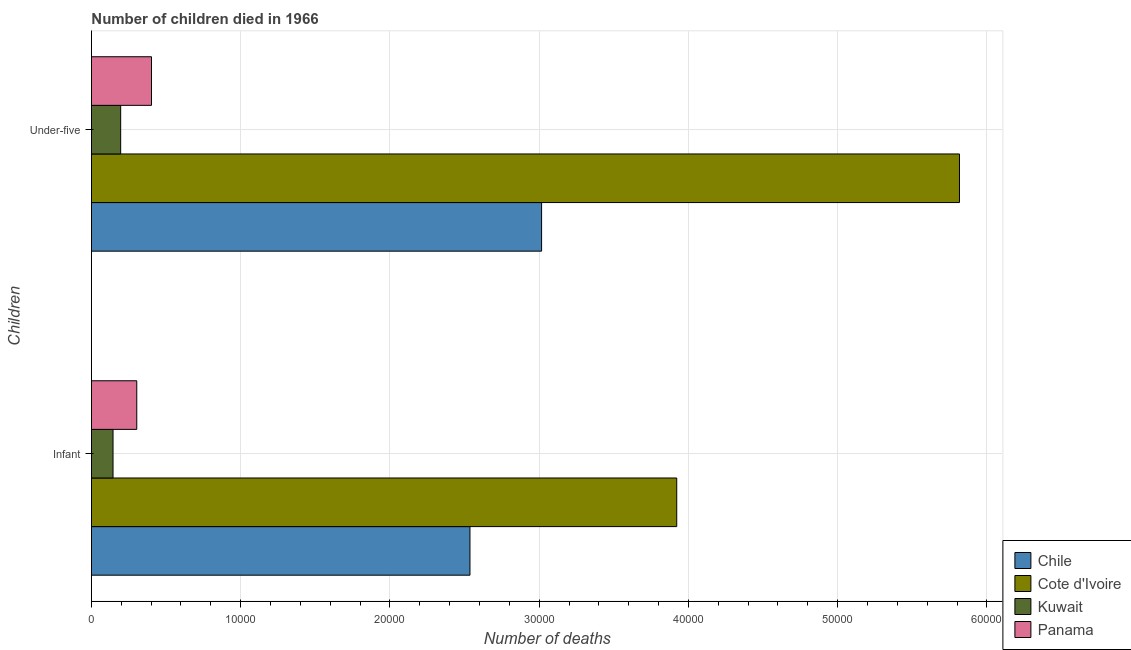How many different coloured bars are there?
Give a very brief answer. 4. Are the number of bars per tick equal to the number of legend labels?
Your response must be concise. Yes. Are the number of bars on each tick of the Y-axis equal?
Provide a short and direct response. Yes. How many bars are there on the 1st tick from the top?
Provide a succinct answer. 4. How many bars are there on the 1st tick from the bottom?
Your answer should be compact. 4. What is the label of the 2nd group of bars from the top?
Your answer should be compact. Infant. What is the number of infant deaths in Panama?
Your answer should be compact. 3038. Across all countries, what is the maximum number of under-five deaths?
Make the answer very short. 5.82e+04. In which country was the number of under-five deaths maximum?
Keep it short and to the point. Cote d'Ivoire. In which country was the number of under-five deaths minimum?
Ensure brevity in your answer.  Kuwait. What is the total number of under-five deaths in the graph?
Ensure brevity in your answer.  9.43e+04. What is the difference between the number of under-five deaths in Chile and that in Kuwait?
Your response must be concise. 2.82e+04. What is the difference between the number of under-five deaths in Cote d'Ivoire and the number of infant deaths in Panama?
Give a very brief answer. 5.51e+04. What is the average number of under-five deaths per country?
Offer a terse response. 2.36e+04. What is the difference between the number of infant deaths and number of under-five deaths in Kuwait?
Your answer should be compact. -512. In how many countries, is the number of under-five deaths greater than 20000 ?
Provide a succinct answer. 2. What is the ratio of the number of under-five deaths in Chile to that in Panama?
Your answer should be compact. 7.49. In how many countries, is the number of infant deaths greater than the average number of infant deaths taken over all countries?
Make the answer very short. 2. What does the 2nd bar from the top in Infant represents?
Keep it short and to the point. Kuwait. What does the 4th bar from the bottom in Under-five represents?
Ensure brevity in your answer.  Panama. How many countries are there in the graph?
Make the answer very short. 4. How many legend labels are there?
Offer a terse response. 4. What is the title of the graph?
Your answer should be very brief. Number of children died in 1966. What is the label or title of the X-axis?
Give a very brief answer. Number of deaths. What is the label or title of the Y-axis?
Your answer should be very brief. Children. What is the Number of deaths of Chile in Infant?
Keep it short and to the point. 2.54e+04. What is the Number of deaths in Cote d'Ivoire in Infant?
Your response must be concise. 3.92e+04. What is the Number of deaths in Kuwait in Infant?
Provide a short and direct response. 1448. What is the Number of deaths in Panama in Infant?
Provide a succinct answer. 3038. What is the Number of deaths in Chile in Under-five?
Provide a short and direct response. 3.02e+04. What is the Number of deaths in Cote d'Ivoire in Under-five?
Provide a short and direct response. 5.82e+04. What is the Number of deaths of Kuwait in Under-five?
Provide a short and direct response. 1960. What is the Number of deaths of Panama in Under-five?
Your answer should be very brief. 4025. Across all Children, what is the maximum Number of deaths in Chile?
Provide a short and direct response. 3.02e+04. Across all Children, what is the maximum Number of deaths in Cote d'Ivoire?
Your response must be concise. 5.82e+04. Across all Children, what is the maximum Number of deaths in Kuwait?
Give a very brief answer. 1960. Across all Children, what is the maximum Number of deaths in Panama?
Offer a very short reply. 4025. Across all Children, what is the minimum Number of deaths in Chile?
Provide a succinct answer. 2.54e+04. Across all Children, what is the minimum Number of deaths of Cote d'Ivoire?
Make the answer very short. 3.92e+04. Across all Children, what is the minimum Number of deaths in Kuwait?
Keep it short and to the point. 1448. Across all Children, what is the minimum Number of deaths in Panama?
Ensure brevity in your answer.  3038. What is the total Number of deaths of Chile in the graph?
Provide a short and direct response. 5.55e+04. What is the total Number of deaths of Cote d'Ivoire in the graph?
Your answer should be compact. 9.74e+04. What is the total Number of deaths in Kuwait in the graph?
Provide a short and direct response. 3408. What is the total Number of deaths of Panama in the graph?
Ensure brevity in your answer.  7063. What is the difference between the Number of deaths of Chile in Infant and that in Under-five?
Ensure brevity in your answer.  -4799. What is the difference between the Number of deaths in Cote d'Ivoire in Infant and that in Under-five?
Give a very brief answer. -1.89e+04. What is the difference between the Number of deaths of Kuwait in Infant and that in Under-five?
Your response must be concise. -512. What is the difference between the Number of deaths in Panama in Infant and that in Under-five?
Ensure brevity in your answer.  -987. What is the difference between the Number of deaths of Chile in Infant and the Number of deaths of Cote d'Ivoire in Under-five?
Your answer should be compact. -3.28e+04. What is the difference between the Number of deaths in Chile in Infant and the Number of deaths in Kuwait in Under-five?
Provide a succinct answer. 2.34e+04. What is the difference between the Number of deaths of Chile in Infant and the Number of deaths of Panama in Under-five?
Provide a succinct answer. 2.13e+04. What is the difference between the Number of deaths of Cote d'Ivoire in Infant and the Number of deaths of Kuwait in Under-five?
Offer a very short reply. 3.73e+04. What is the difference between the Number of deaths in Cote d'Ivoire in Infant and the Number of deaths in Panama in Under-five?
Offer a terse response. 3.52e+04. What is the difference between the Number of deaths in Kuwait in Infant and the Number of deaths in Panama in Under-five?
Your response must be concise. -2577. What is the average Number of deaths of Chile per Children?
Ensure brevity in your answer.  2.78e+04. What is the average Number of deaths of Cote d'Ivoire per Children?
Your response must be concise. 4.87e+04. What is the average Number of deaths in Kuwait per Children?
Offer a very short reply. 1704. What is the average Number of deaths in Panama per Children?
Your response must be concise. 3531.5. What is the difference between the Number of deaths in Chile and Number of deaths in Cote d'Ivoire in Infant?
Give a very brief answer. -1.39e+04. What is the difference between the Number of deaths in Chile and Number of deaths in Kuwait in Infant?
Your response must be concise. 2.39e+04. What is the difference between the Number of deaths in Chile and Number of deaths in Panama in Infant?
Make the answer very short. 2.23e+04. What is the difference between the Number of deaths in Cote d'Ivoire and Number of deaths in Kuwait in Infant?
Give a very brief answer. 3.78e+04. What is the difference between the Number of deaths of Cote d'Ivoire and Number of deaths of Panama in Infant?
Ensure brevity in your answer.  3.62e+04. What is the difference between the Number of deaths in Kuwait and Number of deaths in Panama in Infant?
Offer a very short reply. -1590. What is the difference between the Number of deaths in Chile and Number of deaths in Cote d'Ivoire in Under-five?
Provide a succinct answer. -2.80e+04. What is the difference between the Number of deaths of Chile and Number of deaths of Kuwait in Under-five?
Your response must be concise. 2.82e+04. What is the difference between the Number of deaths of Chile and Number of deaths of Panama in Under-five?
Give a very brief answer. 2.61e+04. What is the difference between the Number of deaths in Cote d'Ivoire and Number of deaths in Kuwait in Under-five?
Offer a terse response. 5.62e+04. What is the difference between the Number of deaths in Cote d'Ivoire and Number of deaths in Panama in Under-five?
Your answer should be compact. 5.41e+04. What is the difference between the Number of deaths of Kuwait and Number of deaths of Panama in Under-five?
Provide a short and direct response. -2065. What is the ratio of the Number of deaths in Chile in Infant to that in Under-five?
Give a very brief answer. 0.84. What is the ratio of the Number of deaths of Cote d'Ivoire in Infant to that in Under-five?
Provide a succinct answer. 0.67. What is the ratio of the Number of deaths in Kuwait in Infant to that in Under-five?
Provide a succinct answer. 0.74. What is the ratio of the Number of deaths of Panama in Infant to that in Under-five?
Your answer should be very brief. 0.75. What is the difference between the highest and the second highest Number of deaths in Chile?
Your response must be concise. 4799. What is the difference between the highest and the second highest Number of deaths in Cote d'Ivoire?
Provide a succinct answer. 1.89e+04. What is the difference between the highest and the second highest Number of deaths of Kuwait?
Make the answer very short. 512. What is the difference between the highest and the second highest Number of deaths in Panama?
Make the answer very short. 987. What is the difference between the highest and the lowest Number of deaths in Chile?
Give a very brief answer. 4799. What is the difference between the highest and the lowest Number of deaths of Cote d'Ivoire?
Offer a very short reply. 1.89e+04. What is the difference between the highest and the lowest Number of deaths in Kuwait?
Offer a terse response. 512. What is the difference between the highest and the lowest Number of deaths of Panama?
Give a very brief answer. 987. 